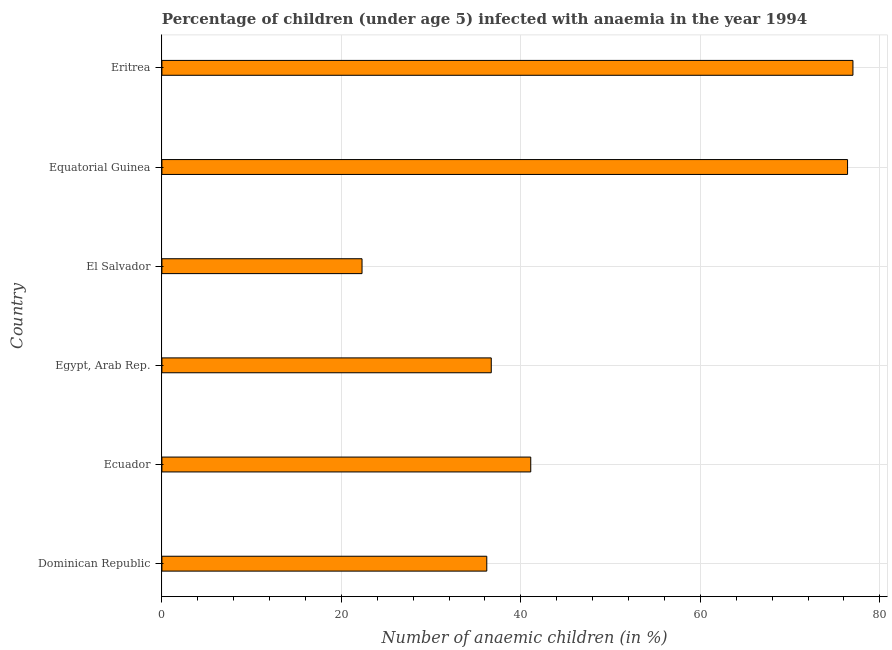Does the graph contain any zero values?
Provide a succinct answer. No. Does the graph contain grids?
Keep it short and to the point. Yes. What is the title of the graph?
Ensure brevity in your answer.  Percentage of children (under age 5) infected with anaemia in the year 1994. What is the label or title of the X-axis?
Give a very brief answer. Number of anaemic children (in %). What is the number of anaemic children in Dominican Republic?
Your answer should be compact. 36.2. Across all countries, what is the maximum number of anaemic children?
Your answer should be compact. 77. Across all countries, what is the minimum number of anaemic children?
Your answer should be compact. 22.3. In which country was the number of anaemic children maximum?
Give a very brief answer. Eritrea. In which country was the number of anaemic children minimum?
Your response must be concise. El Salvador. What is the sum of the number of anaemic children?
Provide a succinct answer. 289.7. What is the average number of anaemic children per country?
Ensure brevity in your answer.  48.28. What is the median number of anaemic children?
Offer a terse response. 38.9. What is the ratio of the number of anaemic children in Egypt, Arab Rep. to that in El Salvador?
Provide a succinct answer. 1.65. Is the number of anaemic children in Dominican Republic less than that in Eritrea?
Your answer should be very brief. Yes. Is the difference between the number of anaemic children in El Salvador and Equatorial Guinea greater than the difference between any two countries?
Your answer should be very brief. No. Is the sum of the number of anaemic children in Dominican Republic and Ecuador greater than the maximum number of anaemic children across all countries?
Provide a succinct answer. Yes. What is the difference between the highest and the lowest number of anaemic children?
Provide a short and direct response. 54.7. How many bars are there?
Provide a short and direct response. 6. What is the difference between two consecutive major ticks on the X-axis?
Your answer should be compact. 20. What is the Number of anaemic children (in %) in Dominican Republic?
Give a very brief answer. 36.2. What is the Number of anaemic children (in %) in Ecuador?
Ensure brevity in your answer.  41.1. What is the Number of anaemic children (in %) in Egypt, Arab Rep.?
Offer a very short reply. 36.7. What is the Number of anaemic children (in %) in El Salvador?
Ensure brevity in your answer.  22.3. What is the Number of anaemic children (in %) in Equatorial Guinea?
Your response must be concise. 76.4. What is the difference between the Number of anaemic children (in %) in Dominican Republic and Egypt, Arab Rep.?
Your answer should be very brief. -0.5. What is the difference between the Number of anaemic children (in %) in Dominican Republic and Equatorial Guinea?
Keep it short and to the point. -40.2. What is the difference between the Number of anaemic children (in %) in Dominican Republic and Eritrea?
Provide a short and direct response. -40.8. What is the difference between the Number of anaemic children (in %) in Ecuador and El Salvador?
Your response must be concise. 18.8. What is the difference between the Number of anaemic children (in %) in Ecuador and Equatorial Guinea?
Provide a short and direct response. -35.3. What is the difference between the Number of anaemic children (in %) in Ecuador and Eritrea?
Keep it short and to the point. -35.9. What is the difference between the Number of anaemic children (in %) in Egypt, Arab Rep. and El Salvador?
Provide a succinct answer. 14.4. What is the difference between the Number of anaemic children (in %) in Egypt, Arab Rep. and Equatorial Guinea?
Keep it short and to the point. -39.7. What is the difference between the Number of anaemic children (in %) in Egypt, Arab Rep. and Eritrea?
Offer a terse response. -40.3. What is the difference between the Number of anaemic children (in %) in El Salvador and Equatorial Guinea?
Your answer should be very brief. -54.1. What is the difference between the Number of anaemic children (in %) in El Salvador and Eritrea?
Offer a very short reply. -54.7. What is the ratio of the Number of anaemic children (in %) in Dominican Republic to that in Ecuador?
Ensure brevity in your answer.  0.88. What is the ratio of the Number of anaemic children (in %) in Dominican Republic to that in Egypt, Arab Rep.?
Provide a succinct answer. 0.99. What is the ratio of the Number of anaemic children (in %) in Dominican Republic to that in El Salvador?
Your answer should be compact. 1.62. What is the ratio of the Number of anaemic children (in %) in Dominican Republic to that in Equatorial Guinea?
Ensure brevity in your answer.  0.47. What is the ratio of the Number of anaemic children (in %) in Dominican Republic to that in Eritrea?
Provide a succinct answer. 0.47. What is the ratio of the Number of anaemic children (in %) in Ecuador to that in Egypt, Arab Rep.?
Offer a terse response. 1.12. What is the ratio of the Number of anaemic children (in %) in Ecuador to that in El Salvador?
Make the answer very short. 1.84. What is the ratio of the Number of anaemic children (in %) in Ecuador to that in Equatorial Guinea?
Give a very brief answer. 0.54. What is the ratio of the Number of anaemic children (in %) in Ecuador to that in Eritrea?
Keep it short and to the point. 0.53. What is the ratio of the Number of anaemic children (in %) in Egypt, Arab Rep. to that in El Salvador?
Provide a short and direct response. 1.65. What is the ratio of the Number of anaemic children (in %) in Egypt, Arab Rep. to that in Equatorial Guinea?
Your answer should be compact. 0.48. What is the ratio of the Number of anaemic children (in %) in Egypt, Arab Rep. to that in Eritrea?
Offer a terse response. 0.48. What is the ratio of the Number of anaemic children (in %) in El Salvador to that in Equatorial Guinea?
Provide a short and direct response. 0.29. What is the ratio of the Number of anaemic children (in %) in El Salvador to that in Eritrea?
Provide a succinct answer. 0.29. What is the ratio of the Number of anaemic children (in %) in Equatorial Guinea to that in Eritrea?
Give a very brief answer. 0.99. 